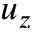Convert formula to latex. <formula><loc_0><loc_0><loc_500><loc_500>u _ { z }</formula> 